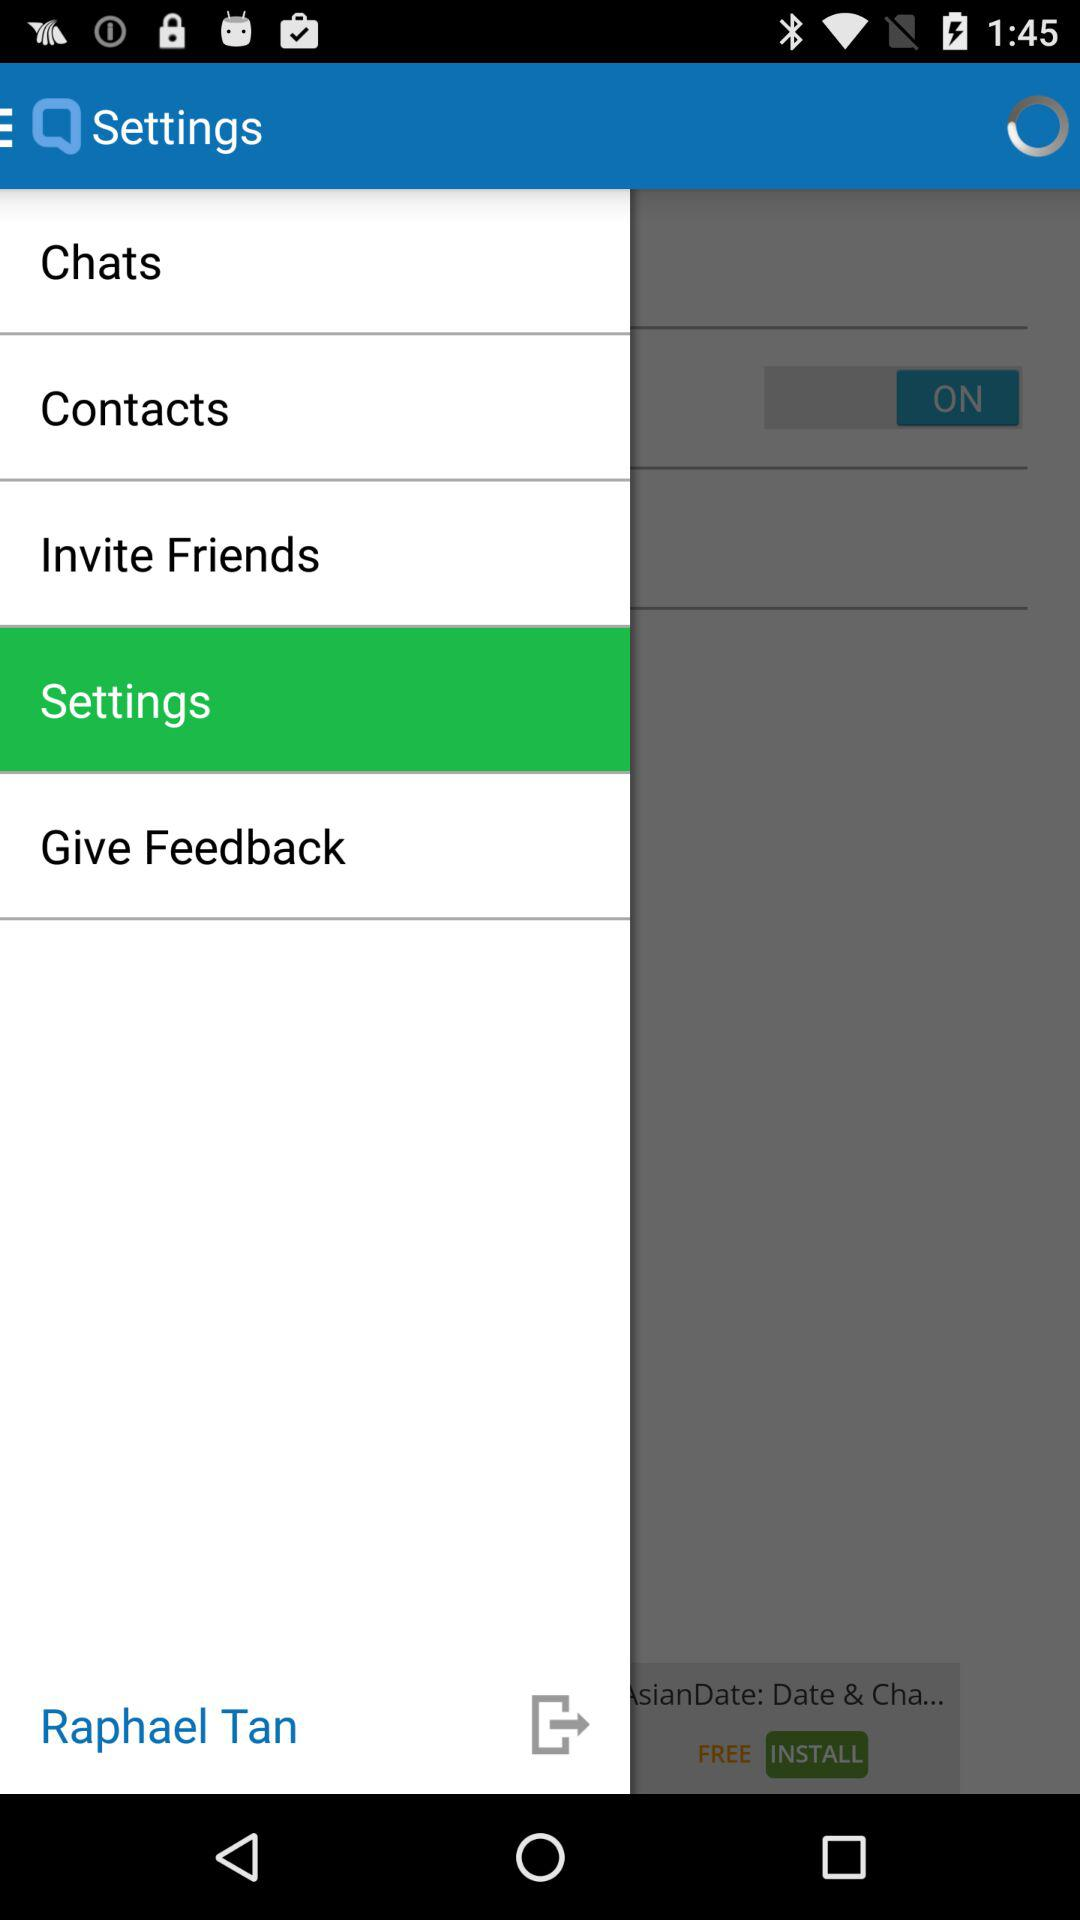Which option is selected? The selected option is "Settings". 